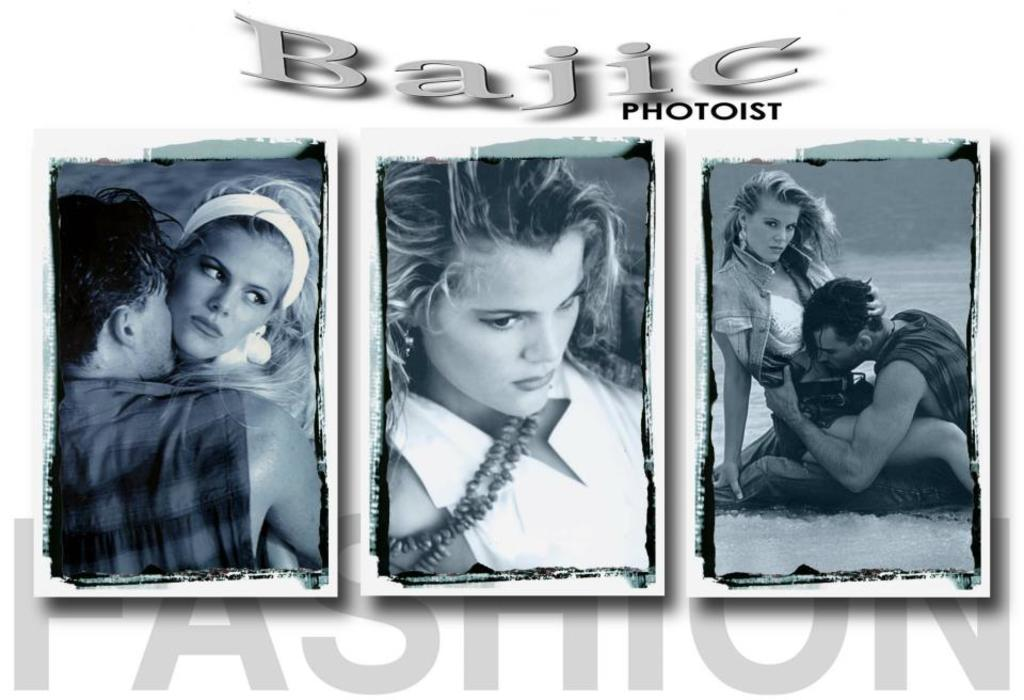How many photos are present in the image? There are three photos in the image. What is depicted in each of the photos? Each photo contains persons. Are there any words or letters present in the photos? Yes, each photo contains text. What type of birds can be seen flying in the background of the photos? There is no mention of birds or any background elements in the provided facts, so it cannot be determined if birds are present in the image. What type of currency is being exchanged in the photos? There is no indication of any currency exchange or transaction in the photos, as the facts only mention the presence of persons and text in each photo. 